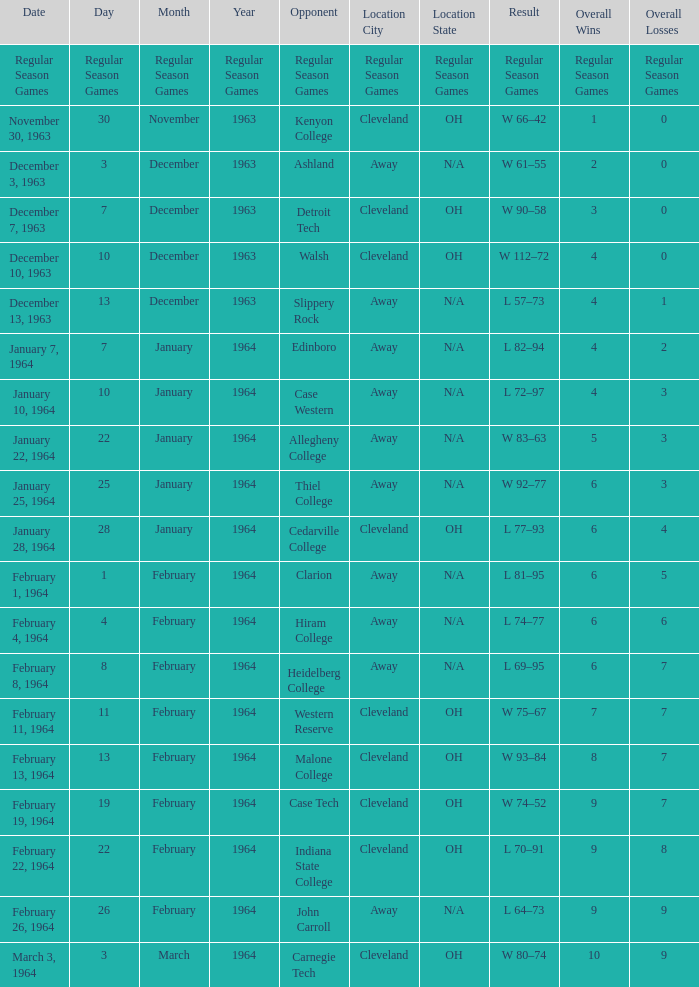What is the Location with a Date that is december 10, 1963? Cleveland, OH. 